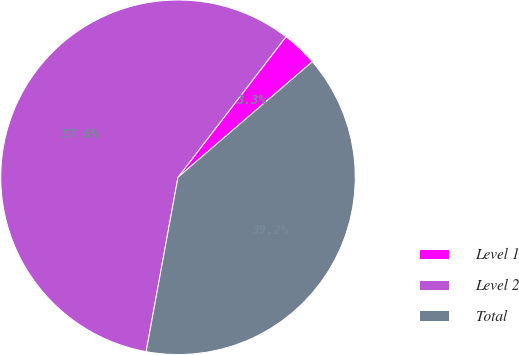Convert chart. <chart><loc_0><loc_0><loc_500><loc_500><pie_chart><fcel>Level 1<fcel>Level 2<fcel>Total<nl><fcel>3.27%<fcel>57.55%<fcel>39.18%<nl></chart> 